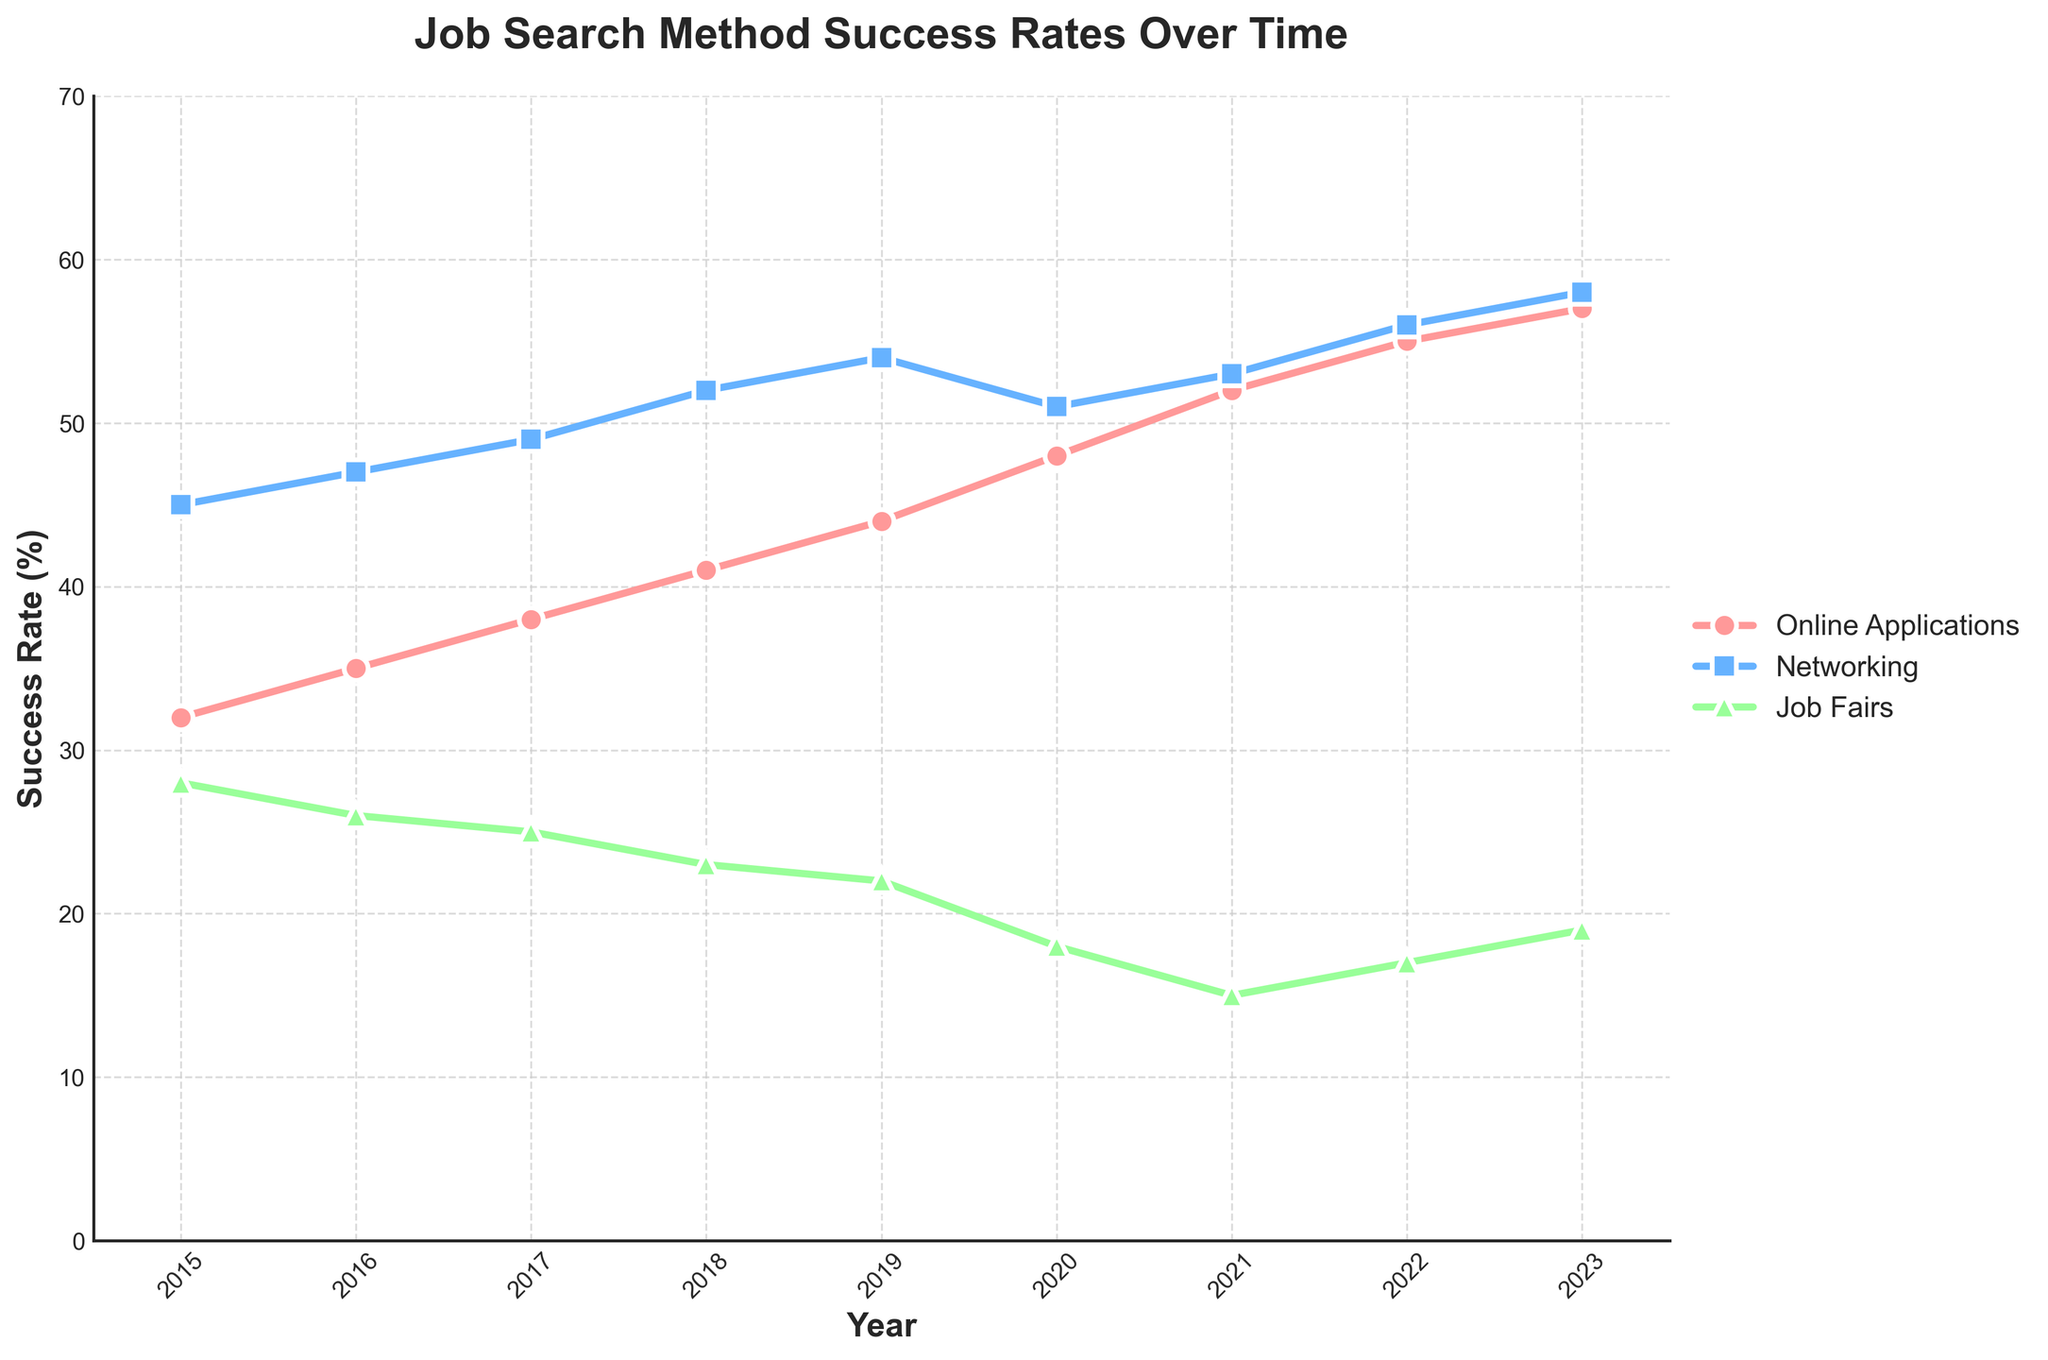What was the success rate of online applications in 2018? Look at the 2018 data point for the pink line (Online Applications) and read the rate.
Answer: 41% In which year did networking have the highest success rate? Identify the highest point on the blue line (Networking) and read the corresponding year from the x-axis.
Answer: 2023 What is the difference in success rates between job fairs and online applications in 2020? Find the success rates of job fairs and online applications in 2020 from their respective lines and subtract the job fairs rate from the online applications rate.
Answer: 30% Which job search method had the lowest success rate in 2021? Compare the success rates of all three methods in 2021, identified by different colored markers.
Answer: Job Fairs What is the average success rate for networking from 2015 to 2023? Add the success rates for networking from 2015 to 2023 and divide by the number of years (9). (45 + 47 + 49 + 52 + 54 + 51 + 53 + 56 + 58)/9 = 465/9
Answer: 51.67% In which year did online applications first surpass a 50% success rate? Find the first year where the pink line (Online Applications) crosses the 50% mark on the y-axis.
Answer: 2021 By how much did the success rate for job fairs decrease from 2015 to 2023? Subtract the success rate for job fairs in 2023 from that in 2015.
Answer: 9% How did the success rates of networking and job fairs compare in 2017? Compare the success rates of the two methods in 2017 by identifying the points on their respective lines. Networking was 49% and job fairs were 25%.
Answer: Networking was 24% higher What is the combined success rate of all methods in 2019? Add the success rates of online applications, networking, and job fairs in 2019. 44 + 54 + 22 = 120
Answer: 120% Which method showed a decline in success rate between 2020 and 2021? Compare the success rates for each method from 2020 to 2021. The green line (Job Fairs) shows a drop from 18% to 15%.
Answer: Job Fairs 